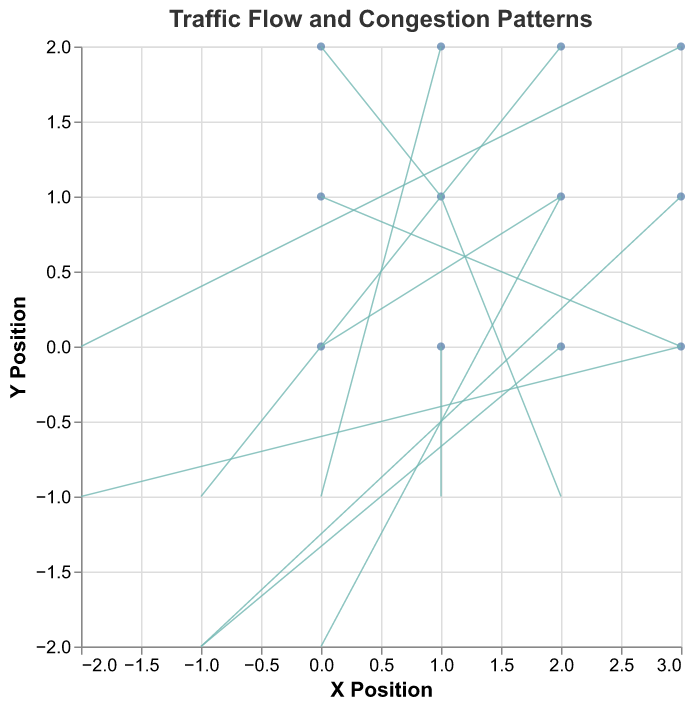What is the title of the plot? The title is displayed at the top of the figure, noting that it's about traffic flow and congestion patterns.
Answer: Traffic Flow and Congestion Patterns How many data points are represented in the plot? Counting from the provided data, there are a total of 12 data points.
Answer: 12 What are the color codes used for points and rules in the plot? Points are colored blue indicating locations, while rules (vector arrows) are green indicating direction and magnitude of traffic.
Answer: Blue and Green At which positions do you observe the highest traffic magnitude? Finding the data points with the highest magnitude in the data table, x=0, y=1 has the highest magnitude of 3.0.
Answer: At (0, 1) Which data points have traffic moving in a northwest direction? Northwest direction means vectors going left and up. By checking data u < 0 and v < 0, we find positions (2,0), (3,1), (2,2).
Answer: (2,0), (3,1), (2,2) At position (1, 1), what is the direction and magnitude of the traffic flow? According to the data, the vector (2, -1) indicates the flow is moving right and slightly down with a magnitude of 2.2.
Answer: Right and slightly down, magnitude 2.2 Compare traffic flow magnitude between (0, 0) and (3, 0). Which is higher? The magnitude at (0, 0) is 2.2, while the magnitude at (3, 0) is also 2.2. They are equal.
Answer: They are equal What is the average magnitude of traffic flow at y = 2? At y=2, magnitudes are 1.4, 1.0, 1.4 at (0, 2), (1, 2), (2, 2). So, (1.4 + 1.0 + 1.4)/3 = 1.27
Answer: 1.27 Which direction does traffic flow predominantly move at x = 3? At x=3, the vectors are (-2,-1), (-1,-2), and (-2,0) suggesting a general westward and slightly southward flow.
Answer: Westward and slightly southward What is the magnitude of traffic at the central position in the grid? The central position is (1,1) where the magnitude is noted as 2.2 in the data table.
Answer: 2.2 